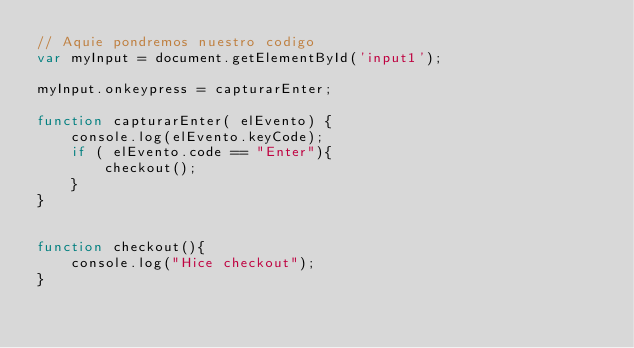<code> <loc_0><loc_0><loc_500><loc_500><_JavaScript_>// Aquie pondremos nuestro codigo
var myInput = document.getElementById('input1');

myInput.onkeypress = capturarEnter;

function capturarEnter( elEvento) {
    console.log(elEvento.keyCode);
    if ( elEvento.code == "Enter"){
        checkout();
    }
}


function checkout(){
    console.log("Hice checkout");
}</code> 